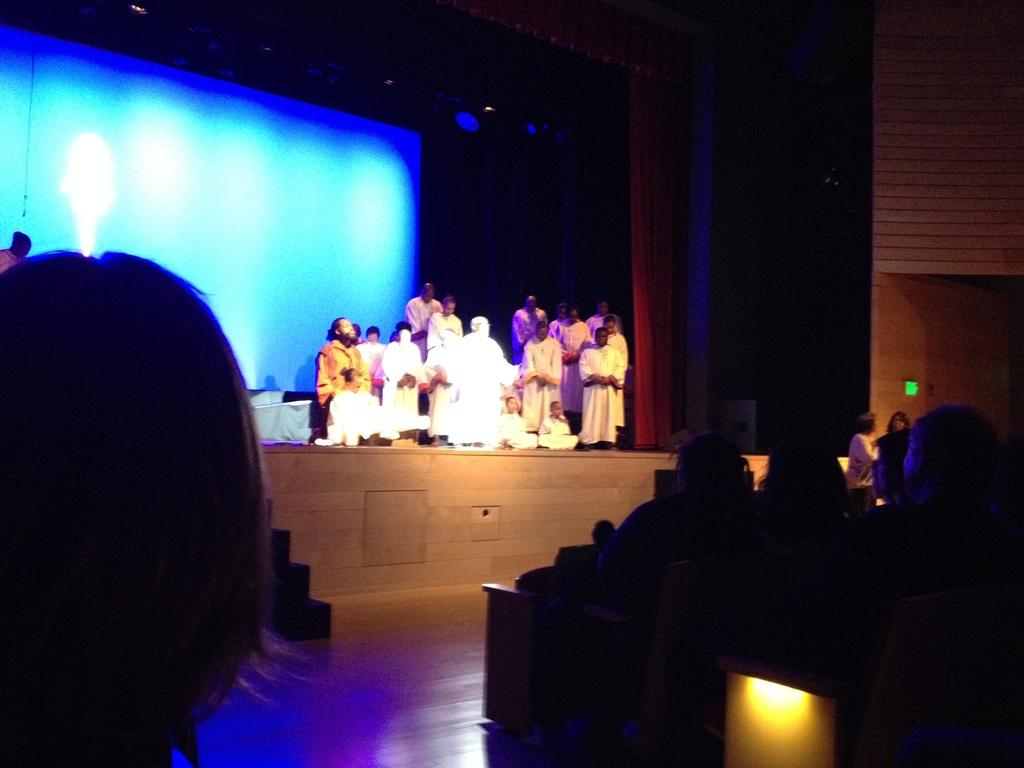What are the people in the image doing? The people in the image are sitting on chairs. What can be seen in the background of the image? There is a stage in the background of the image. What is happening on the stage? There are people performing an act on the stage. What else is present in the image besides the chairs and stage? There is a screen in the image. How many parents are present in the image? There is no mention of parents in the image, so we cannot determine the number of parents present. 